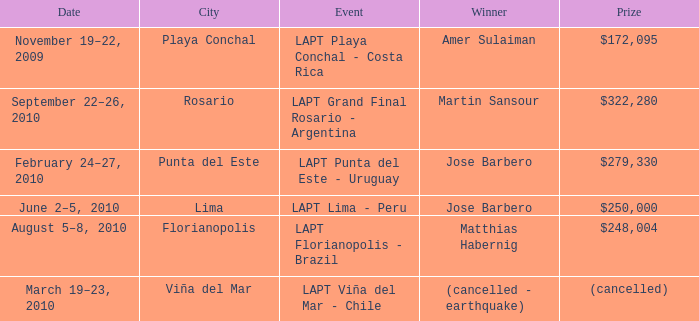Who is the winner in the city of lima? Jose Barbero. I'm looking to parse the entire table for insights. Could you assist me with that? {'header': ['Date', 'City', 'Event', 'Winner', 'Prize'], 'rows': [['November 19–22, 2009', 'Playa Conchal', 'LAPT Playa Conchal - Costa Rica', 'Amer Sulaiman', '$172,095'], ['September 22–26, 2010', 'Rosario', 'LAPT Grand Final Rosario - Argentina', 'Martin Sansour', '$322,280'], ['February 24–27, 2010', 'Punta del Este', 'LAPT Punta del Este - Uruguay', 'Jose Barbero', '$279,330'], ['June 2–5, 2010', 'Lima', 'LAPT Lima - Peru', 'Jose Barbero', '$250,000'], ['August 5–8, 2010', 'Florianopolis', 'LAPT Florianopolis - Brazil', 'Matthias Habernig', '$248,004'], ['March 19–23, 2010', 'Viña del Mar', 'LAPT Viña del Mar - Chile', '(cancelled - earthquake)', '(cancelled)']]} 